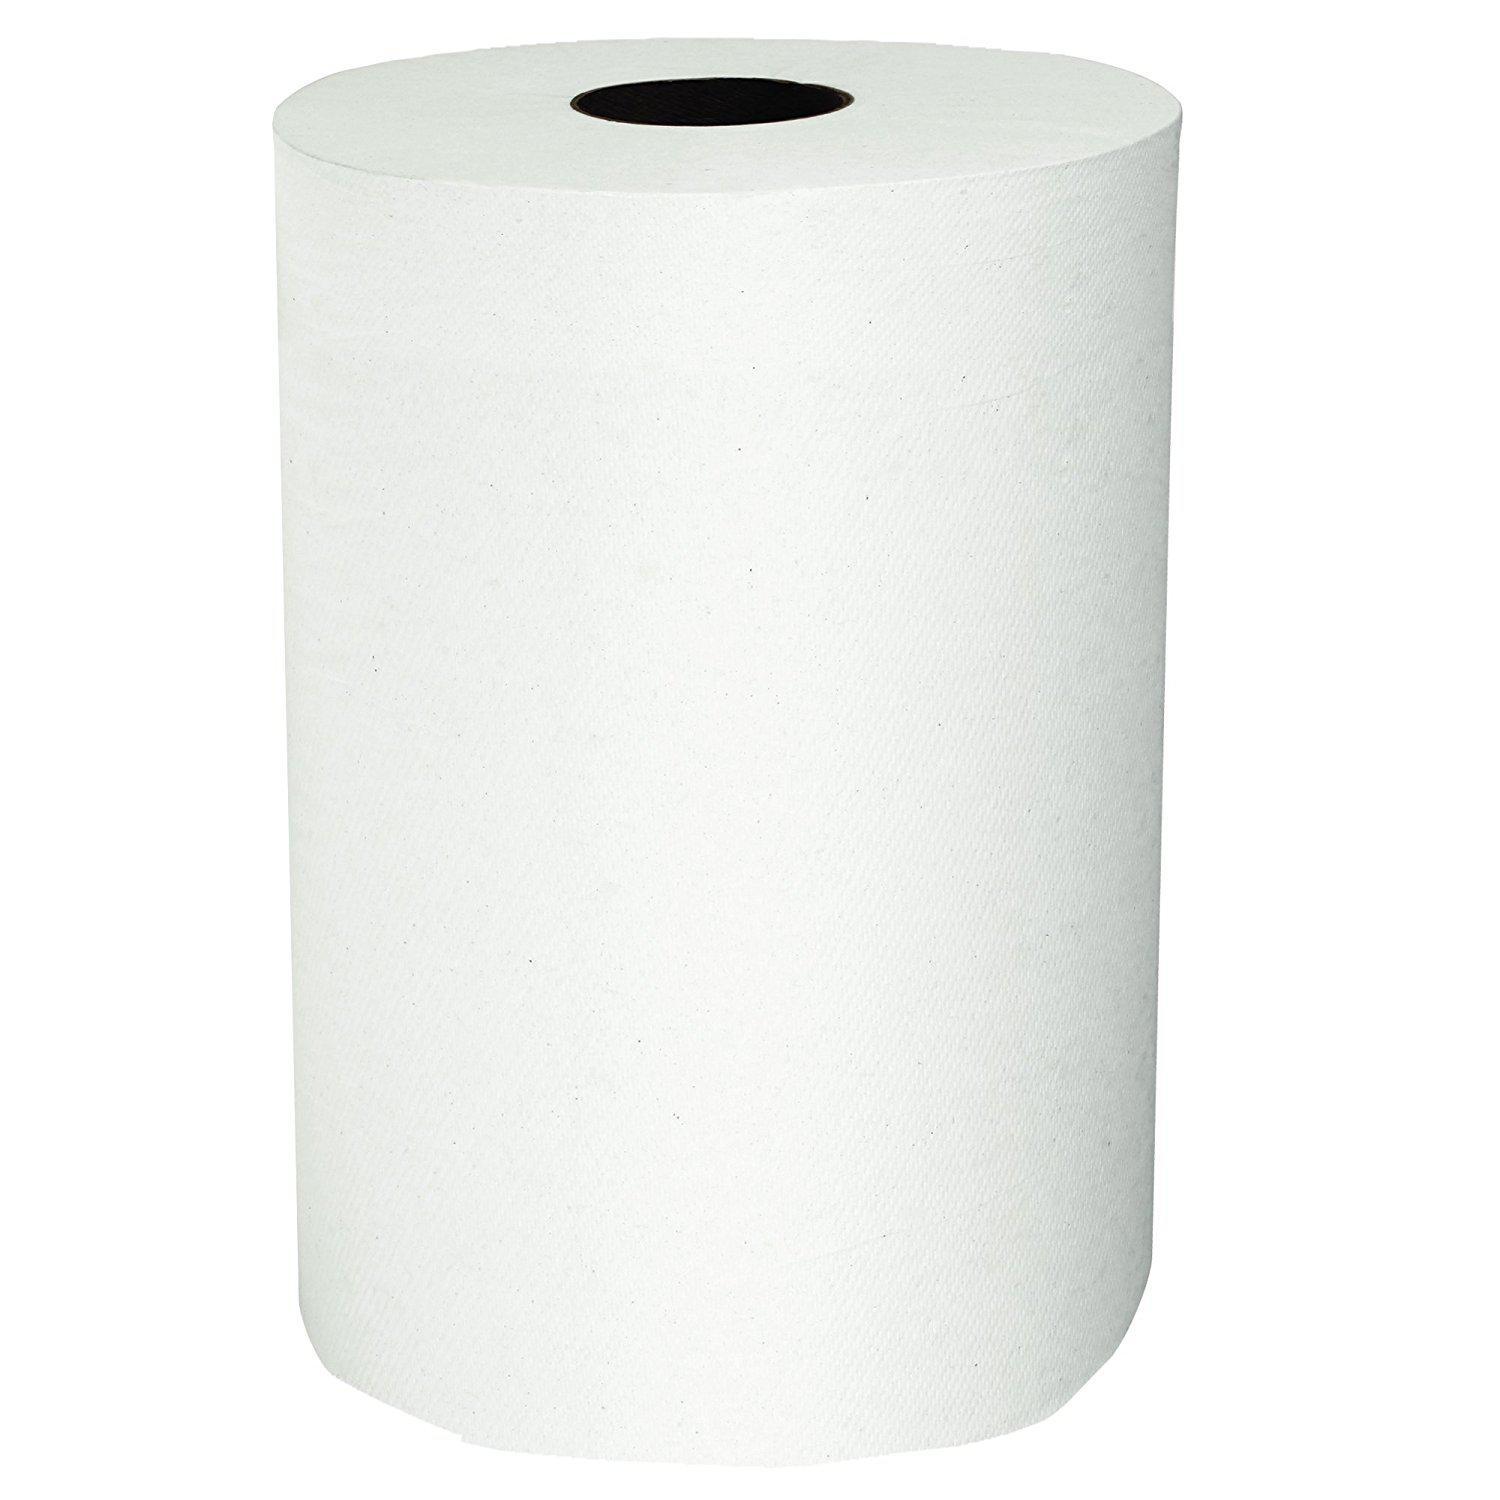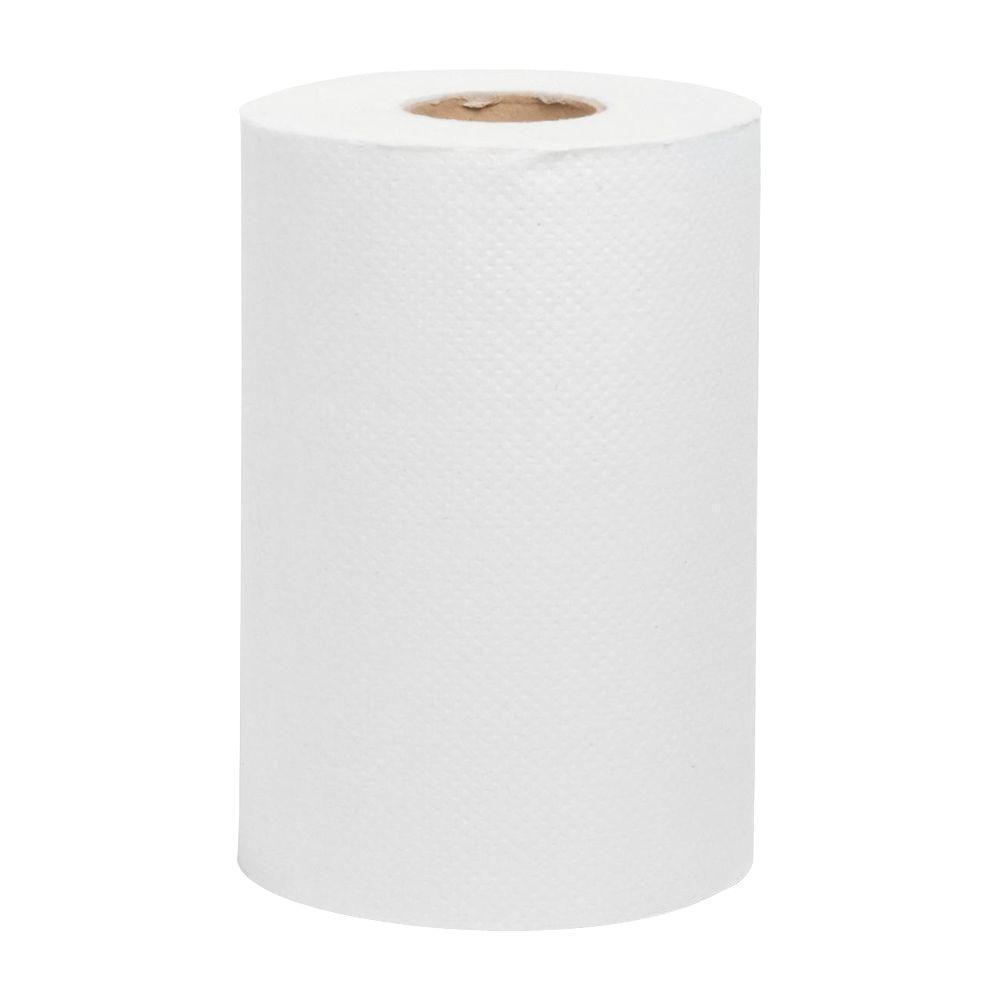The first image is the image on the left, the second image is the image on the right. Considering the images on both sides, is "Each image features a single white upright roll of paper towels with no sheet of towel extending out past the roll." valid? Answer yes or no. Yes. The first image is the image on the left, the second image is the image on the right. For the images displayed, is the sentence "In at least one image there is a single role of toilet paper with and open unruptured hole in the middle with the paper unrolling at least one sheet." factually correct? Answer yes or no. No. 